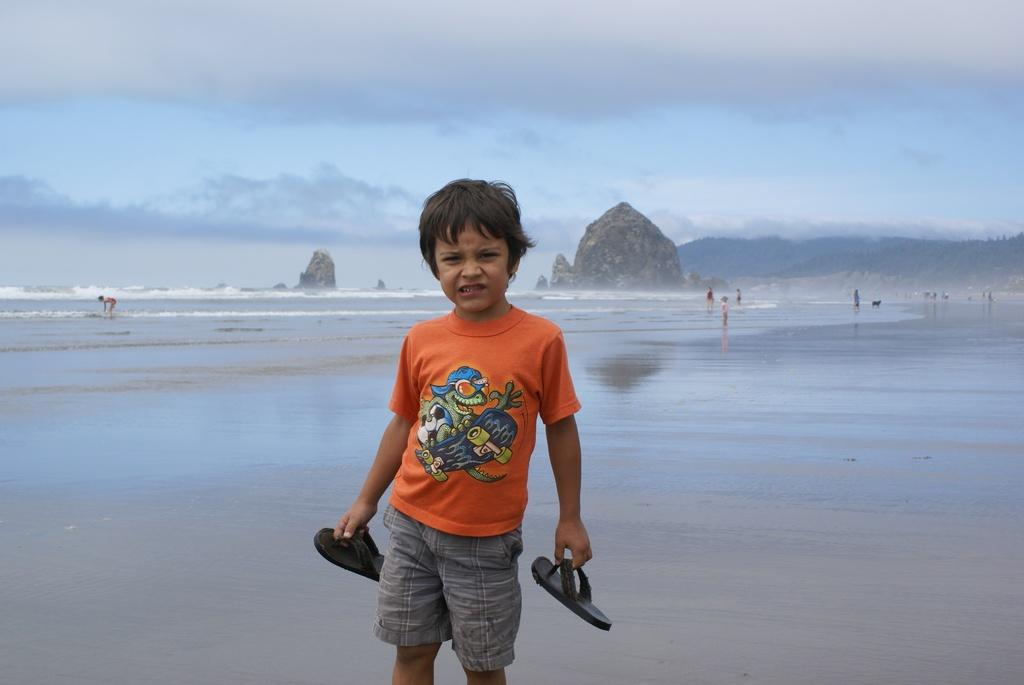Who is the main subject in the image? There is a boy in the image. What is the boy wearing? The boy is wearing an orange t-shirt. What is the boy holding in his hand? The boy is holding slippers in his hand. What can be seen in the background of the image? There is water, mountains, and a cloudy sky visible in the background of the image. How does the crowd react to the boy's actions in the image? There is no crowd present in the image, so it is not possible to determine how they might react to the boy's actions. 